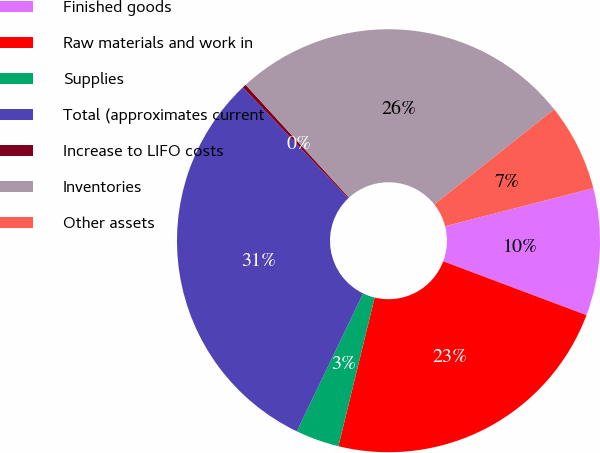Convert chart. <chart><loc_0><loc_0><loc_500><loc_500><pie_chart><fcel>Finished goods<fcel>Raw materials and work in<fcel>Supplies<fcel>Total (approximates current<fcel>Increase to LIFO costs<fcel>Inventories<fcel>Other assets<nl><fcel>9.72%<fcel>23.08%<fcel>3.33%<fcel>30.77%<fcel>0.29%<fcel>26.13%<fcel>6.67%<nl></chart> 